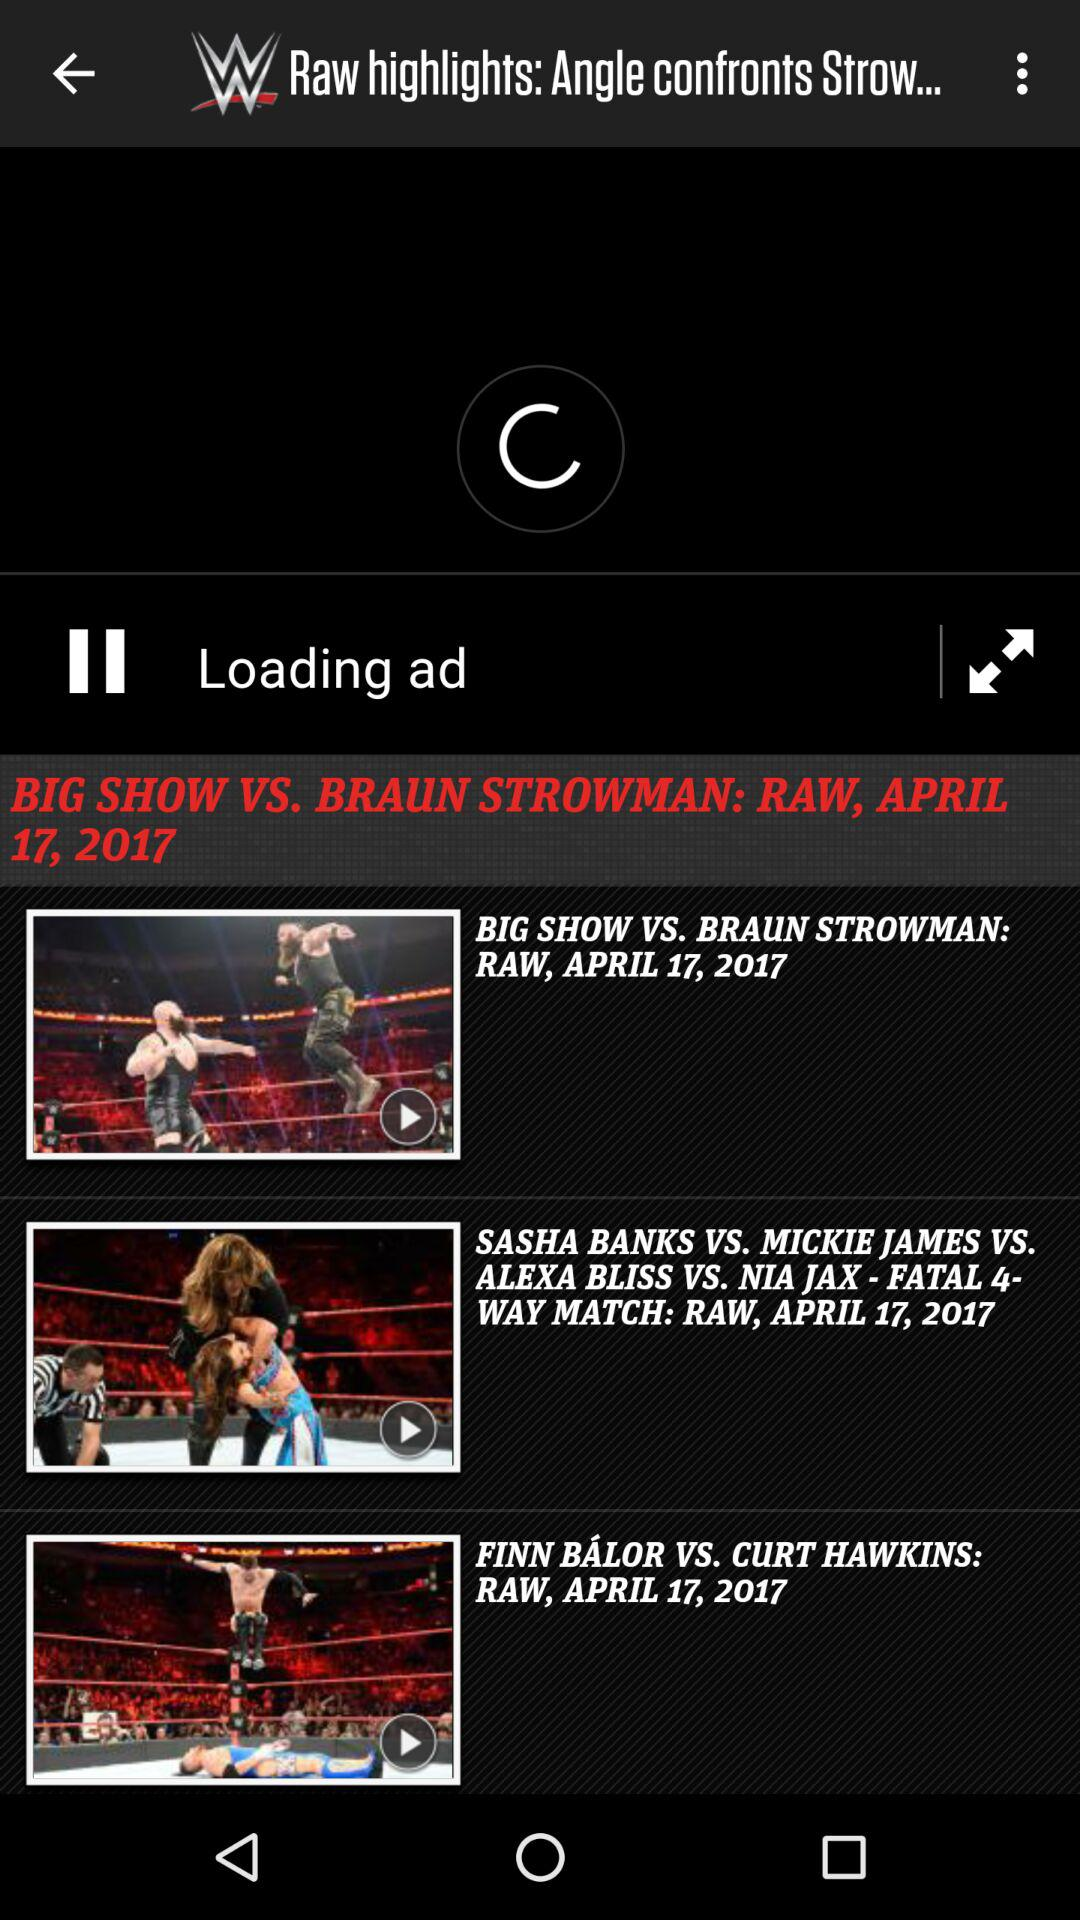When was the video of Finn Balor vs. Curt Hawkins match is updated?
When the provided information is insufficient, respond with <no answer>. <no answer> 